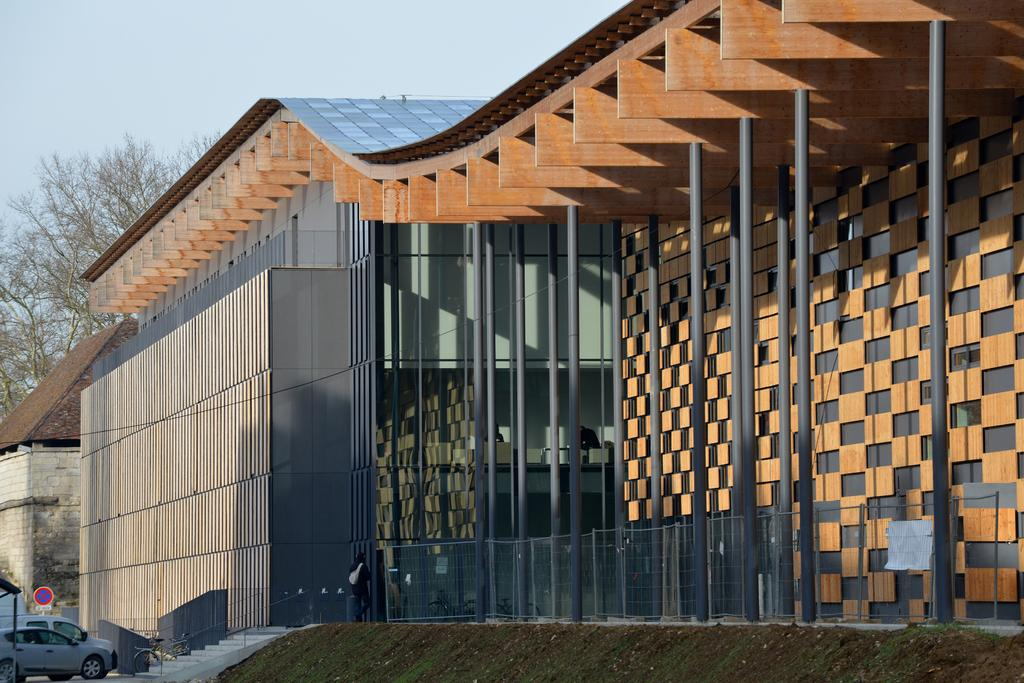What type of structure is visible in the image? There is a building in the image. What can be seen on the left side of the image? There are cars parked at the left side of the image. What type of vegetation is present in the image? There is a tree in the image. What is the condition of the sky in the image? The sky is clear in the image. How old is the baby in the image? There is no baby present in the image. What type of dish is the daughter cooking in the image? There is no daughter or cooking activity present in the image. 